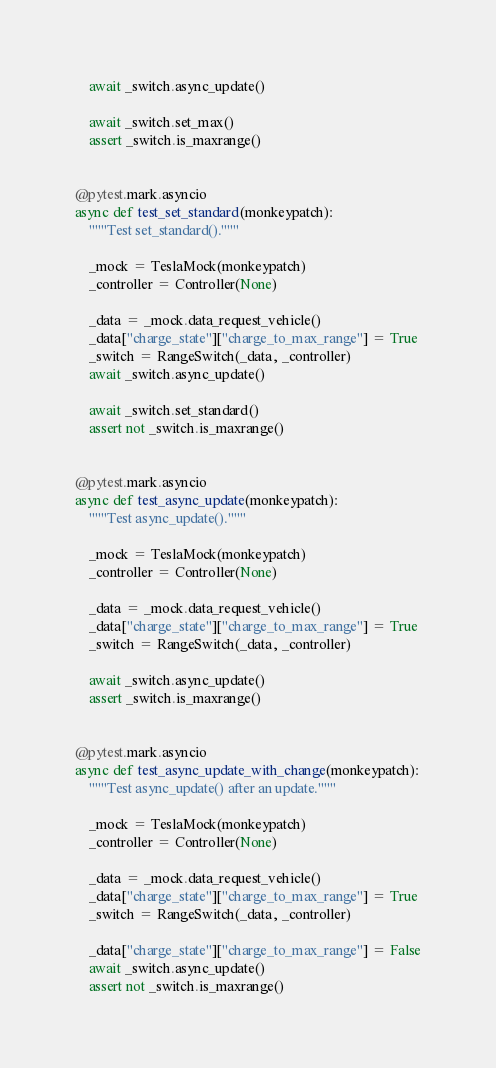<code> <loc_0><loc_0><loc_500><loc_500><_Python_>    await _switch.async_update()

    await _switch.set_max()
    assert _switch.is_maxrange()


@pytest.mark.asyncio
async def test_set_standard(monkeypatch):
    """Test set_standard()."""

    _mock = TeslaMock(monkeypatch)
    _controller = Controller(None)

    _data = _mock.data_request_vehicle()
    _data["charge_state"]["charge_to_max_range"] = True
    _switch = RangeSwitch(_data, _controller)
    await _switch.async_update()

    await _switch.set_standard()
    assert not _switch.is_maxrange()


@pytest.mark.asyncio
async def test_async_update(monkeypatch):
    """Test async_update()."""

    _mock = TeslaMock(monkeypatch)
    _controller = Controller(None)

    _data = _mock.data_request_vehicle()
    _data["charge_state"]["charge_to_max_range"] = True
    _switch = RangeSwitch(_data, _controller)

    await _switch.async_update()
    assert _switch.is_maxrange()


@pytest.mark.asyncio
async def test_async_update_with_change(monkeypatch):
    """Test async_update() after an update."""

    _mock = TeslaMock(monkeypatch)
    _controller = Controller(None)

    _data = _mock.data_request_vehicle()
    _data["charge_state"]["charge_to_max_range"] = True
    _switch = RangeSwitch(_data, _controller)

    _data["charge_state"]["charge_to_max_range"] = False
    await _switch.async_update()
    assert not _switch.is_maxrange()
</code> 